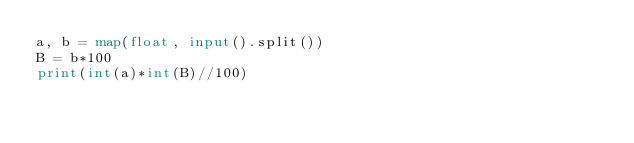Convert code to text. <code><loc_0><loc_0><loc_500><loc_500><_Python_>a, b = map(float, input().split())
B = b*100
print(int(a)*int(B)//100)
</code> 